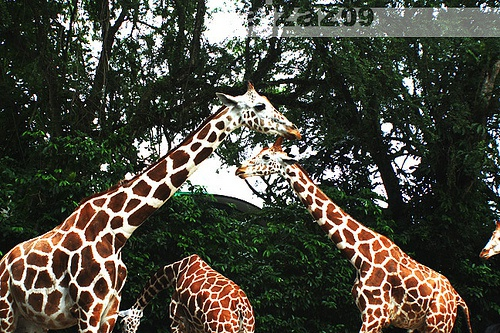Describe the objects in this image and their specific colors. I can see giraffe in black, white, maroon, and tan tones, giraffe in black, ivory, maroon, and brown tones, giraffe in black, ivory, maroon, and brown tones, and giraffe in black, ivory, khaki, and orange tones in this image. 